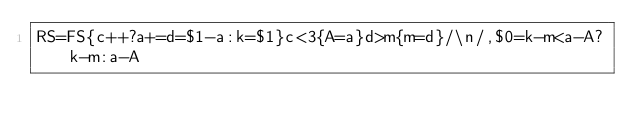<code> <loc_0><loc_0><loc_500><loc_500><_Awk_>RS=FS{c++?a+=d=$1-a:k=$1}c<3{A=a}d>m{m=d}/\n/,$0=k-m<a-A?k-m:a-A</code> 